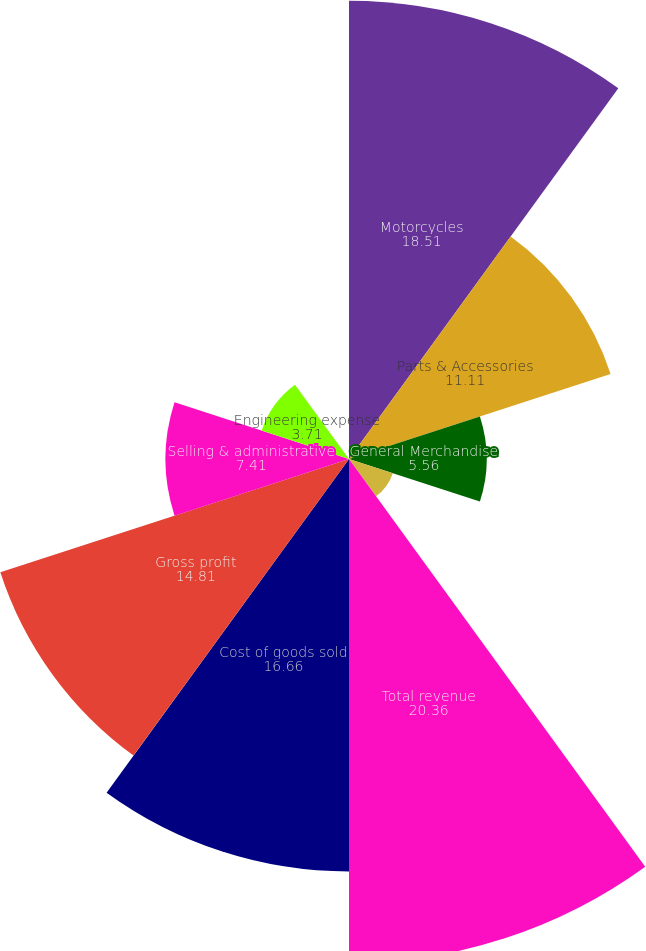<chart> <loc_0><loc_0><loc_500><loc_500><pie_chart><fcel>Motorcycles<fcel>Parts & Accessories<fcel>General Merchandise<fcel>Other<fcel>Total revenue<fcel>Cost of goods sold<fcel>Gross profit<fcel>Selling & administrative<fcel>Engineering expense<fcel>Restructuring (benefit)<nl><fcel>18.51%<fcel>11.11%<fcel>5.56%<fcel>1.86%<fcel>20.36%<fcel>16.66%<fcel>14.81%<fcel>7.41%<fcel>3.71%<fcel>0.01%<nl></chart> 